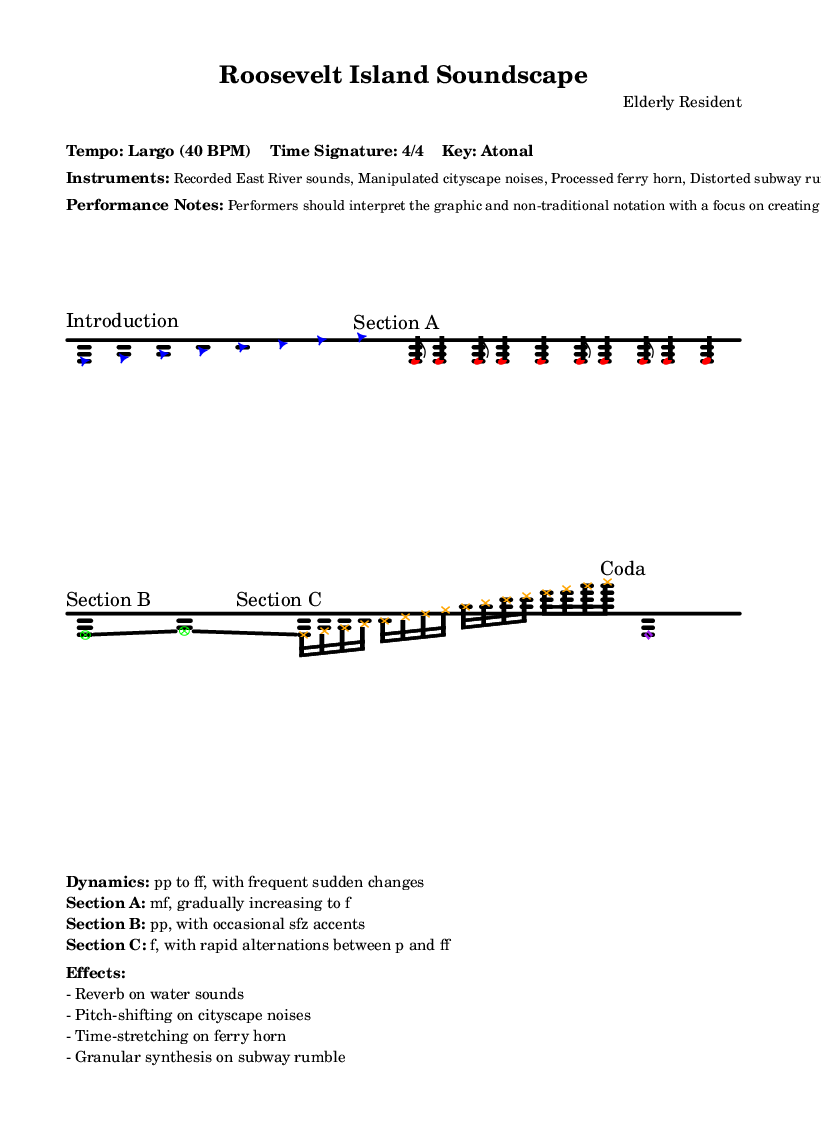What is the tempo of this piece? The tempo is indicated at the beginning of the sheet music as "Largo (40 BPM)", which suggests a slow speed of performance.
Answer: Largo (40 BPM) What is the time signature? The time signature is explicitly noted as "4/4" in the markings, indicating four beats per measure.
Answer: 4/4 What instruments are used? The instruments listed include "Recorded East River sounds, Manipulated cityscape noises, Processed ferry horn, Distorted subway rumble", providing a unique sound palette for this piece.
Answer: Recorded East River sounds, Manipulated cityscape noises, Processed ferry horn, Distorted subway rumble What is the dynamic range in Section A? The dynamic range for Section A is marked as "mf, gradually increasing to f", suggesting a build from medium soft to loud.
Answer: mf, gradually increasing to f How does Section B differ from Section A? Section B is noted to be "pp, with occasional sfz accents", indicating a much softer volume than Section A, which starts at "mf". This requires performers to adapt their playing style notably between these sections.
Answer: pp, with occasional sfz accents What is the significance of the extended techniques? Extended techniques are especially important in this piece as they allow performers to create unconventional sounds that mimic or enhance the urban soundscape of Roosevelt Island. The notation encourages improvisation and interpretation, which is a hallmark of experimental music practices.
Answer: Sonic representation of Roosevelt Island's urban environment Which effect is applied to the ferry horn? The sheet mentions that the ferry horn undergoes "Time-stretching", which alters its duration and potentially affects its pitch and texture during performance.
Answer: Time-stretching 